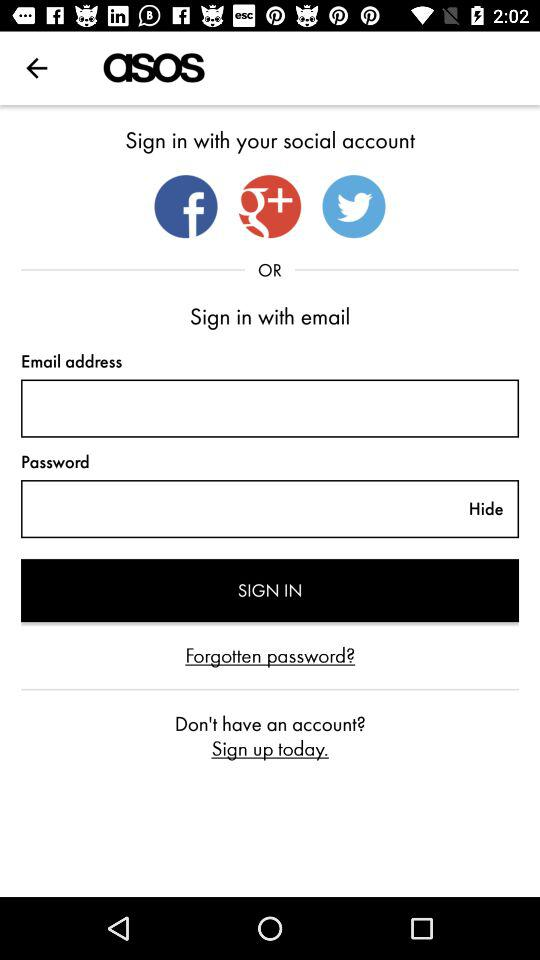What is the application name? The application name is "asos". 